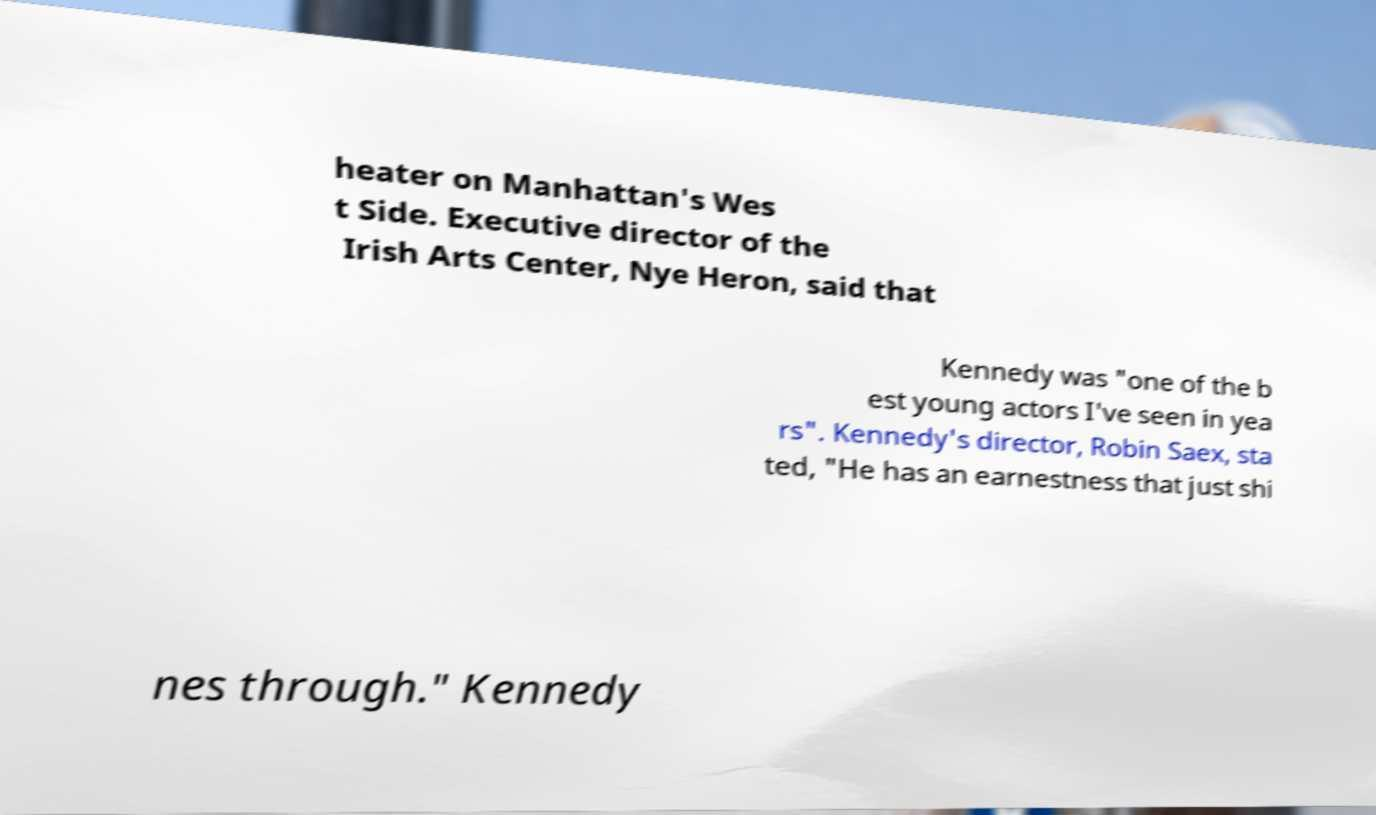Could you extract and type out the text from this image? heater on Manhattan's Wes t Side. Executive director of the Irish Arts Center, Nye Heron, said that Kennedy was "one of the b est young actors I've seen in yea rs". Kennedy's director, Robin Saex, sta ted, "He has an earnestness that just shi nes through." Kennedy 